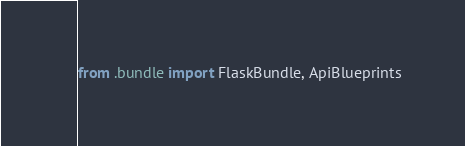<code> <loc_0><loc_0><loc_500><loc_500><_Python_>from .bundle import FlaskBundle, ApiBlueprints
</code> 